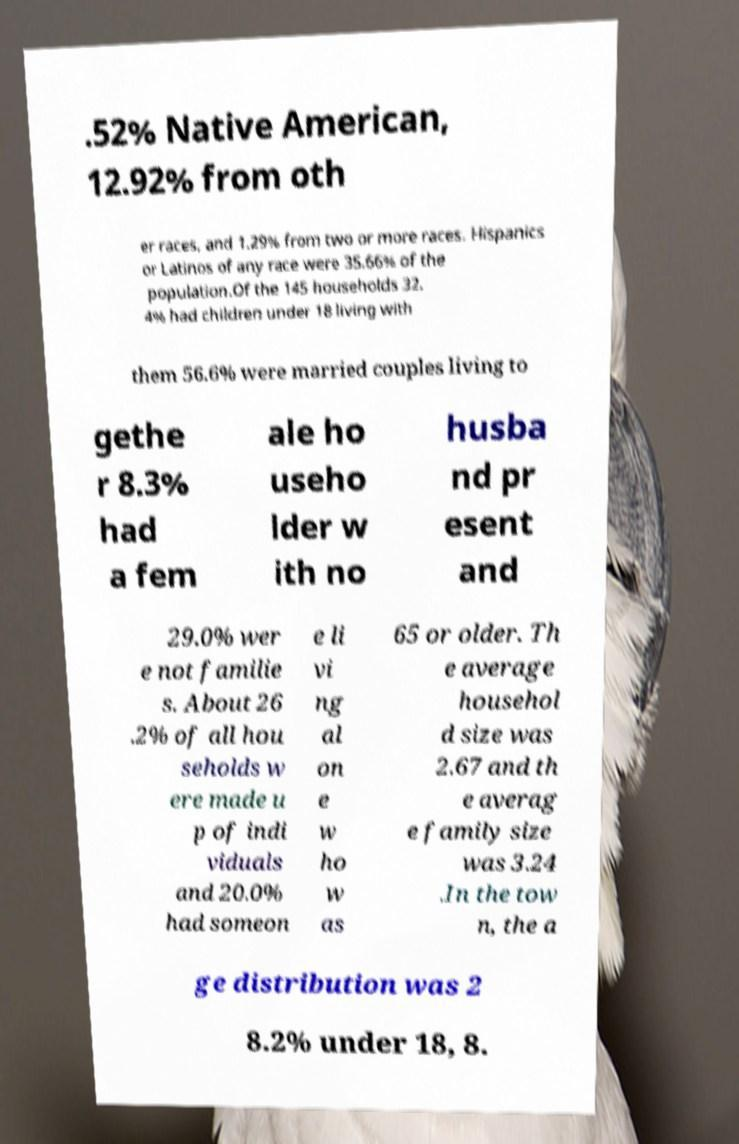I need the written content from this picture converted into text. Can you do that? .52% Native American, 12.92% from oth er races, and 1.29% from two or more races. Hispanics or Latinos of any race were 35.66% of the population.Of the 145 households 32. 4% had children under 18 living with them 56.6% were married couples living to gethe r 8.3% had a fem ale ho useho lder w ith no husba nd pr esent and 29.0% wer e not familie s. About 26 .2% of all hou seholds w ere made u p of indi viduals and 20.0% had someon e li vi ng al on e w ho w as 65 or older. Th e average househol d size was 2.67 and th e averag e family size was 3.24 .In the tow n, the a ge distribution was 2 8.2% under 18, 8. 